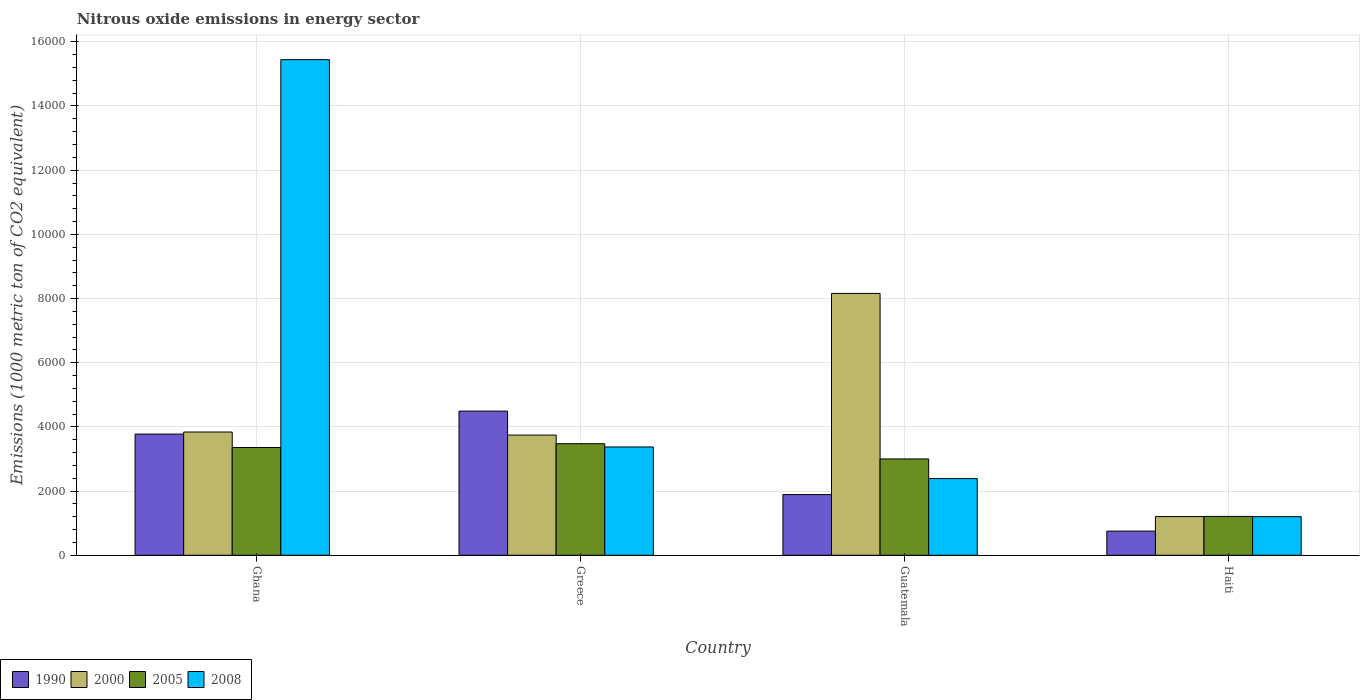What is the label of the 1st group of bars from the left?
Provide a short and direct response. Ghana. In how many cases, is the number of bars for a given country not equal to the number of legend labels?
Ensure brevity in your answer.  0. What is the amount of nitrous oxide emitted in 2008 in Guatemala?
Provide a succinct answer. 2390. Across all countries, what is the maximum amount of nitrous oxide emitted in 1990?
Ensure brevity in your answer.  4492.8. Across all countries, what is the minimum amount of nitrous oxide emitted in 2000?
Provide a short and direct response. 1206.3. In which country was the amount of nitrous oxide emitted in 2008 minimum?
Offer a very short reply. Haiti. What is the total amount of nitrous oxide emitted in 2008 in the graph?
Provide a short and direct response. 2.24e+04. What is the difference between the amount of nitrous oxide emitted in 2005 in Guatemala and that in Haiti?
Offer a very short reply. 1791.3. What is the difference between the amount of nitrous oxide emitted in 2005 in Guatemala and the amount of nitrous oxide emitted in 2000 in Haiti?
Ensure brevity in your answer.  1796.1. What is the average amount of nitrous oxide emitted in 1990 per country?
Keep it short and to the point. 2728.48. What is the difference between the amount of nitrous oxide emitted of/in 2005 and amount of nitrous oxide emitted of/in 1990 in Greece?
Provide a succinct answer. -1015.8. What is the ratio of the amount of nitrous oxide emitted in 1990 in Guatemala to that in Haiti?
Your response must be concise. 2.51. Is the amount of nitrous oxide emitted in 2000 in Guatemala less than that in Haiti?
Ensure brevity in your answer.  No. Is the difference between the amount of nitrous oxide emitted in 2005 in Ghana and Guatemala greater than the difference between the amount of nitrous oxide emitted in 1990 in Ghana and Guatemala?
Give a very brief answer. No. What is the difference between the highest and the second highest amount of nitrous oxide emitted in 2000?
Ensure brevity in your answer.  95.3. What is the difference between the highest and the lowest amount of nitrous oxide emitted in 2008?
Give a very brief answer. 1.42e+04. In how many countries, is the amount of nitrous oxide emitted in 2008 greater than the average amount of nitrous oxide emitted in 2008 taken over all countries?
Provide a short and direct response. 1. Is it the case that in every country, the sum of the amount of nitrous oxide emitted in 2005 and amount of nitrous oxide emitted in 1990 is greater than the sum of amount of nitrous oxide emitted in 2008 and amount of nitrous oxide emitted in 2000?
Offer a terse response. No. What does the 1st bar from the left in Greece represents?
Keep it short and to the point. 1990. Is it the case that in every country, the sum of the amount of nitrous oxide emitted in 2000 and amount of nitrous oxide emitted in 1990 is greater than the amount of nitrous oxide emitted in 2005?
Provide a succinct answer. Yes. Are all the bars in the graph horizontal?
Ensure brevity in your answer.  No. Are the values on the major ticks of Y-axis written in scientific E-notation?
Your answer should be compact. No. Does the graph contain grids?
Your answer should be compact. Yes. How are the legend labels stacked?
Provide a succinct answer. Horizontal. What is the title of the graph?
Keep it short and to the point. Nitrous oxide emissions in energy sector. What is the label or title of the Y-axis?
Provide a short and direct response. Emissions (1000 metric ton of CO2 equivalent). What is the Emissions (1000 metric ton of CO2 equivalent) in 1990 in Ghana?
Ensure brevity in your answer.  3776.4. What is the Emissions (1000 metric ton of CO2 equivalent) in 2000 in Ghana?
Your response must be concise. 3840.8. What is the Emissions (1000 metric ton of CO2 equivalent) of 2005 in Ghana?
Offer a terse response. 3358.7. What is the Emissions (1000 metric ton of CO2 equivalent) in 2008 in Ghana?
Offer a very short reply. 1.54e+04. What is the Emissions (1000 metric ton of CO2 equivalent) of 1990 in Greece?
Provide a succinct answer. 4492.8. What is the Emissions (1000 metric ton of CO2 equivalent) in 2000 in Greece?
Give a very brief answer. 3745.5. What is the Emissions (1000 metric ton of CO2 equivalent) of 2005 in Greece?
Ensure brevity in your answer.  3477. What is the Emissions (1000 metric ton of CO2 equivalent) in 2008 in Greece?
Your answer should be compact. 3375. What is the Emissions (1000 metric ton of CO2 equivalent) in 1990 in Guatemala?
Provide a succinct answer. 1891.2. What is the Emissions (1000 metric ton of CO2 equivalent) in 2000 in Guatemala?
Offer a very short reply. 8159.4. What is the Emissions (1000 metric ton of CO2 equivalent) of 2005 in Guatemala?
Keep it short and to the point. 3002.4. What is the Emissions (1000 metric ton of CO2 equivalent) in 2008 in Guatemala?
Your answer should be very brief. 2390. What is the Emissions (1000 metric ton of CO2 equivalent) of 1990 in Haiti?
Give a very brief answer. 753.5. What is the Emissions (1000 metric ton of CO2 equivalent) in 2000 in Haiti?
Keep it short and to the point. 1206.3. What is the Emissions (1000 metric ton of CO2 equivalent) of 2005 in Haiti?
Make the answer very short. 1211.1. What is the Emissions (1000 metric ton of CO2 equivalent) of 2008 in Haiti?
Give a very brief answer. 1203.2. Across all countries, what is the maximum Emissions (1000 metric ton of CO2 equivalent) of 1990?
Your answer should be very brief. 4492.8. Across all countries, what is the maximum Emissions (1000 metric ton of CO2 equivalent) in 2000?
Keep it short and to the point. 8159.4. Across all countries, what is the maximum Emissions (1000 metric ton of CO2 equivalent) in 2005?
Ensure brevity in your answer.  3477. Across all countries, what is the maximum Emissions (1000 metric ton of CO2 equivalent) of 2008?
Make the answer very short. 1.54e+04. Across all countries, what is the minimum Emissions (1000 metric ton of CO2 equivalent) in 1990?
Your answer should be very brief. 753.5. Across all countries, what is the minimum Emissions (1000 metric ton of CO2 equivalent) in 2000?
Provide a succinct answer. 1206.3. Across all countries, what is the minimum Emissions (1000 metric ton of CO2 equivalent) in 2005?
Your response must be concise. 1211.1. Across all countries, what is the minimum Emissions (1000 metric ton of CO2 equivalent) of 2008?
Offer a very short reply. 1203.2. What is the total Emissions (1000 metric ton of CO2 equivalent) in 1990 in the graph?
Your answer should be very brief. 1.09e+04. What is the total Emissions (1000 metric ton of CO2 equivalent) in 2000 in the graph?
Offer a very short reply. 1.70e+04. What is the total Emissions (1000 metric ton of CO2 equivalent) of 2005 in the graph?
Keep it short and to the point. 1.10e+04. What is the total Emissions (1000 metric ton of CO2 equivalent) of 2008 in the graph?
Provide a succinct answer. 2.24e+04. What is the difference between the Emissions (1000 metric ton of CO2 equivalent) in 1990 in Ghana and that in Greece?
Provide a succinct answer. -716.4. What is the difference between the Emissions (1000 metric ton of CO2 equivalent) of 2000 in Ghana and that in Greece?
Your answer should be compact. 95.3. What is the difference between the Emissions (1000 metric ton of CO2 equivalent) of 2005 in Ghana and that in Greece?
Give a very brief answer. -118.3. What is the difference between the Emissions (1000 metric ton of CO2 equivalent) of 2008 in Ghana and that in Greece?
Offer a terse response. 1.21e+04. What is the difference between the Emissions (1000 metric ton of CO2 equivalent) of 1990 in Ghana and that in Guatemala?
Your answer should be compact. 1885.2. What is the difference between the Emissions (1000 metric ton of CO2 equivalent) of 2000 in Ghana and that in Guatemala?
Your answer should be compact. -4318.6. What is the difference between the Emissions (1000 metric ton of CO2 equivalent) in 2005 in Ghana and that in Guatemala?
Make the answer very short. 356.3. What is the difference between the Emissions (1000 metric ton of CO2 equivalent) of 2008 in Ghana and that in Guatemala?
Offer a terse response. 1.31e+04. What is the difference between the Emissions (1000 metric ton of CO2 equivalent) in 1990 in Ghana and that in Haiti?
Your response must be concise. 3022.9. What is the difference between the Emissions (1000 metric ton of CO2 equivalent) in 2000 in Ghana and that in Haiti?
Offer a very short reply. 2634.5. What is the difference between the Emissions (1000 metric ton of CO2 equivalent) of 2005 in Ghana and that in Haiti?
Ensure brevity in your answer.  2147.6. What is the difference between the Emissions (1000 metric ton of CO2 equivalent) in 2008 in Ghana and that in Haiti?
Keep it short and to the point. 1.42e+04. What is the difference between the Emissions (1000 metric ton of CO2 equivalent) in 1990 in Greece and that in Guatemala?
Offer a terse response. 2601.6. What is the difference between the Emissions (1000 metric ton of CO2 equivalent) of 2000 in Greece and that in Guatemala?
Provide a short and direct response. -4413.9. What is the difference between the Emissions (1000 metric ton of CO2 equivalent) in 2005 in Greece and that in Guatemala?
Keep it short and to the point. 474.6. What is the difference between the Emissions (1000 metric ton of CO2 equivalent) in 2008 in Greece and that in Guatemala?
Your answer should be very brief. 985. What is the difference between the Emissions (1000 metric ton of CO2 equivalent) in 1990 in Greece and that in Haiti?
Offer a terse response. 3739.3. What is the difference between the Emissions (1000 metric ton of CO2 equivalent) in 2000 in Greece and that in Haiti?
Provide a short and direct response. 2539.2. What is the difference between the Emissions (1000 metric ton of CO2 equivalent) of 2005 in Greece and that in Haiti?
Offer a very short reply. 2265.9. What is the difference between the Emissions (1000 metric ton of CO2 equivalent) in 2008 in Greece and that in Haiti?
Your response must be concise. 2171.8. What is the difference between the Emissions (1000 metric ton of CO2 equivalent) of 1990 in Guatemala and that in Haiti?
Your answer should be very brief. 1137.7. What is the difference between the Emissions (1000 metric ton of CO2 equivalent) of 2000 in Guatemala and that in Haiti?
Provide a succinct answer. 6953.1. What is the difference between the Emissions (1000 metric ton of CO2 equivalent) of 2005 in Guatemala and that in Haiti?
Your response must be concise. 1791.3. What is the difference between the Emissions (1000 metric ton of CO2 equivalent) in 2008 in Guatemala and that in Haiti?
Provide a short and direct response. 1186.8. What is the difference between the Emissions (1000 metric ton of CO2 equivalent) of 1990 in Ghana and the Emissions (1000 metric ton of CO2 equivalent) of 2000 in Greece?
Your answer should be very brief. 30.9. What is the difference between the Emissions (1000 metric ton of CO2 equivalent) in 1990 in Ghana and the Emissions (1000 metric ton of CO2 equivalent) in 2005 in Greece?
Give a very brief answer. 299.4. What is the difference between the Emissions (1000 metric ton of CO2 equivalent) of 1990 in Ghana and the Emissions (1000 metric ton of CO2 equivalent) of 2008 in Greece?
Provide a short and direct response. 401.4. What is the difference between the Emissions (1000 metric ton of CO2 equivalent) in 2000 in Ghana and the Emissions (1000 metric ton of CO2 equivalent) in 2005 in Greece?
Your response must be concise. 363.8. What is the difference between the Emissions (1000 metric ton of CO2 equivalent) in 2000 in Ghana and the Emissions (1000 metric ton of CO2 equivalent) in 2008 in Greece?
Ensure brevity in your answer.  465.8. What is the difference between the Emissions (1000 metric ton of CO2 equivalent) in 2005 in Ghana and the Emissions (1000 metric ton of CO2 equivalent) in 2008 in Greece?
Offer a very short reply. -16.3. What is the difference between the Emissions (1000 metric ton of CO2 equivalent) in 1990 in Ghana and the Emissions (1000 metric ton of CO2 equivalent) in 2000 in Guatemala?
Ensure brevity in your answer.  -4383. What is the difference between the Emissions (1000 metric ton of CO2 equivalent) of 1990 in Ghana and the Emissions (1000 metric ton of CO2 equivalent) of 2005 in Guatemala?
Ensure brevity in your answer.  774. What is the difference between the Emissions (1000 metric ton of CO2 equivalent) of 1990 in Ghana and the Emissions (1000 metric ton of CO2 equivalent) of 2008 in Guatemala?
Your response must be concise. 1386.4. What is the difference between the Emissions (1000 metric ton of CO2 equivalent) in 2000 in Ghana and the Emissions (1000 metric ton of CO2 equivalent) in 2005 in Guatemala?
Offer a very short reply. 838.4. What is the difference between the Emissions (1000 metric ton of CO2 equivalent) of 2000 in Ghana and the Emissions (1000 metric ton of CO2 equivalent) of 2008 in Guatemala?
Your response must be concise. 1450.8. What is the difference between the Emissions (1000 metric ton of CO2 equivalent) in 2005 in Ghana and the Emissions (1000 metric ton of CO2 equivalent) in 2008 in Guatemala?
Your answer should be very brief. 968.7. What is the difference between the Emissions (1000 metric ton of CO2 equivalent) in 1990 in Ghana and the Emissions (1000 metric ton of CO2 equivalent) in 2000 in Haiti?
Provide a short and direct response. 2570.1. What is the difference between the Emissions (1000 metric ton of CO2 equivalent) in 1990 in Ghana and the Emissions (1000 metric ton of CO2 equivalent) in 2005 in Haiti?
Give a very brief answer. 2565.3. What is the difference between the Emissions (1000 metric ton of CO2 equivalent) in 1990 in Ghana and the Emissions (1000 metric ton of CO2 equivalent) in 2008 in Haiti?
Offer a terse response. 2573.2. What is the difference between the Emissions (1000 metric ton of CO2 equivalent) of 2000 in Ghana and the Emissions (1000 metric ton of CO2 equivalent) of 2005 in Haiti?
Your response must be concise. 2629.7. What is the difference between the Emissions (1000 metric ton of CO2 equivalent) in 2000 in Ghana and the Emissions (1000 metric ton of CO2 equivalent) in 2008 in Haiti?
Keep it short and to the point. 2637.6. What is the difference between the Emissions (1000 metric ton of CO2 equivalent) in 2005 in Ghana and the Emissions (1000 metric ton of CO2 equivalent) in 2008 in Haiti?
Your answer should be very brief. 2155.5. What is the difference between the Emissions (1000 metric ton of CO2 equivalent) in 1990 in Greece and the Emissions (1000 metric ton of CO2 equivalent) in 2000 in Guatemala?
Offer a very short reply. -3666.6. What is the difference between the Emissions (1000 metric ton of CO2 equivalent) of 1990 in Greece and the Emissions (1000 metric ton of CO2 equivalent) of 2005 in Guatemala?
Provide a short and direct response. 1490.4. What is the difference between the Emissions (1000 metric ton of CO2 equivalent) in 1990 in Greece and the Emissions (1000 metric ton of CO2 equivalent) in 2008 in Guatemala?
Your answer should be very brief. 2102.8. What is the difference between the Emissions (1000 metric ton of CO2 equivalent) of 2000 in Greece and the Emissions (1000 metric ton of CO2 equivalent) of 2005 in Guatemala?
Offer a very short reply. 743.1. What is the difference between the Emissions (1000 metric ton of CO2 equivalent) in 2000 in Greece and the Emissions (1000 metric ton of CO2 equivalent) in 2008 in Guatemala?
Your answer should be very brief. 1355.5. What is the difference between the Emissions (1000 metric ton of CO2 equivalent) in 2005 in Greece and the Emissions (1000 metric ton of CO2 equivalent) in 2008 in Guatemala?
Your answer should be compact. 1087. What is the difference between the Emissions (1000 metric ton of CO2 equivalent) of 1990 in Greece and the Emissions (1000 metric ton of CO2 equivalent) of 2000 in Haiti?
Offer a terse response. 3286.5. What is the difference between the Emissions (1000 metric ton of CO2 equivalent) in 1990 in Greece and the Emissions (1000 metric ton of CO2 equivalent) in 2005 in Haiti?
Your answer should be compact. 3281.7. What is the difference between the Emissions (1000 metric ton of CO2 equivalent) of 1990 in Greece and the Emissions (1000 metric ton of CO2 equivalent) of 2008 in Haiti?
Keep it short and to the point. 3289.6. What is the difference between the Emissions (1000 metric ton of CO2 equivalent) in 2000 in Greece and the Emissions (1000 metric ton of CO2 equivalent) in 2005 in Haiti?
Keep it short and to the point. 2534.4. What is the difference between the Emissions (1000 metric ton of CO2 equivalent) in 2000 in Greece and the Emissions (1000 metric ton of CO2 equivalent) in 2008 in Haiti?
Offer a terse response. 2542.3. What is the difference between the Emissions (1000 metric ton of CO2 equivalent) of 2005 in Greece and the Emissions (1000 metric ton of CO2 equivalent) of 2008 in Haiti?
Your answer should be very brief. 2273.8. What is the difference between the Emissions (1000 metric ton of CO2 equivalent) in 1990 in Guatemala and the Emissions (1000 metric ton of CO2 equivalent) in 2000 in Haiti?
Provide a short and direct response. 684.9. What is the difference between the Emissions (1000 metric ton of CO2 equivalent) of 1990 in Guatemala and the Emissions (1000 metric ton of CO2 equivalent) of 2005 in Haiti?
Make the answer very short. 680.1. What is the difference between the Emissions (1000 metric ton of CO2 equivalent) of 1990 in Guatemala and the Emissions (1000 metric ton of CO2 equivalent) of 2008 in Haiti?
Your answer should be compact. 688. What is the difference between the Emissions (1000 metric ton of CO2 equivalent) in 2000 in Guatemala and the Emissions (1000 metric ton of CO2 equivalent) in 2005 in Haiti?
Ensure brevity in your answer.  6948.3. What is the difference between the Emissions (1000 metric ton of CO2 equivalent) of 2000 in Guatemala and the Emissions (1000 metric ton of CO2 equivalent) of 2008 in Haiti?
Your answer should be compact. 6956.2. What is the difference between the Emissions (1000 metric ton of CO2 equivalent) in 2005 in Guatemala and the Emissions (1000 metric ton of CO2 equivalent) in 2008 in Haiti?
Your answer should be very brief. 1799.2. What is the average Emissions (1000 metric ton of CO2 equivalent) in 1990 per country?
Offer a very short reply. 2728.47. What is the average Emissions (1000 metric ton of CO2 equivalent) of 2000 per country?
Give a very brief answer. 4238. What is the average Emissions (1000 metric ton of CO2 equivalent) of 2005 per country?
Make the answer very short. 2762.3. What is the average Emissions (1000 metric ton of CO2 equivalent) in 2008 per country?
Keep it short and to the point. 5603.07. What is the difference between the Emissions (1000 metric ton of CO2 equivalent) of 1990 and Emissions (1000 metric ton of CO2 equivalent) of 2000 in Ghana?
Your answer should be compact. -64.4. What is the difference between the Emissions (1000 metric ton of CO2 equivalent) in 1990 and Emissions (1000 metric ton of CO2 equivalent) in 2005 in Ghana?
Your answer should be compact. 417.7. What is the difference between the Emissions (1000 metric ton of CO2 equivalent) of 1990 and Emissions (1000 metric ton of CO2 equivalent) of 2008 in Ghana?
Make the answer very short. -1.17e+04. What is the difference between the Emissions (1000 metric ton of CO2 equivalent) in 2000 and Emissions (1000 metric ton of CO2 equivalent) in 2005 in Ghana?
Your response must be concise. 482.1. What is the difference between the Emissions (1000 metric ton of CO2 equivalent) of 2000 and Emissions (1000 metric ton of CO2 equivalent) of 2008 in Ghana?
Offer a very short reply. -1.16e+04. What is the difference between the Emissions (1000 metric ton of CO2 equivalent) in 2005 and Emissions (1000 metric ton of CO2 equivalent) in 2008 in Ghana?
Keep it short and to the point. -1.21e+04. What is the difference between the Emissions (1000 metric ton of CO2 equivalent) of 1990 and Emissions (1000 metric ton of CO2 equivalent) of 2000 in Greece?
Make the answer very short. 747.3. What is the difference between the Emissions (1000 metric ton of CO2 equivalent) in 1990 and Emissions (1000 metric ton of CO2 equivalent) in 2005 in Greece?
Your answer should be very brief. 1015.8. What is the difference between the Emissions (1000 metric ton of CO2 equivalent) in 1990 and Emissions (1000 metric ton of CO2 equivalent) in 2008 in Greece?
Give a very brief answer. 1117.8. What is the difference between the Emissions (1000 metric ton of CO2 equivalent) of 2000 and Emissions (1000 metric ton of CO2 equivalent) of 2005 in Greece?
Provide a succinct answer. 268.5. What is the difference between the Emissions (1000 metric ton of CO2 equivalent) of 2000 and Emissions (1000 metric ton of CO2 equivalent) of 2008 in Greece?
Your response must be concise. 370.5. What is the difference between the Emissions (1000 metric ton of CO2 equivalent) of 2005 and Emissions (1000 metric ton of CO2 equivalent) of 2008 in Greece?
Provide a succinct answer. 102. What is the difference between the Emissions (1000 metric ton of CO2 equivalent) of 1990 and Emissions (1000 metric ton of CO2 equivalent) of 2000 in Guatemala?
Ensure brevity in your answer.  -6268.2. What is the difference between the Emissions (1000 metric ton of CO2 equivalent) in 1990 and Emissions (1000 metric ton of CO2 equivalent) in 2005 in Guatemala?
Provide a succinct answer. -1111.2. What is the difference between the Emissions (1000 metric ton of CO2 equivalent) in 1990 and Emissions (1000 metric ton of CO2 equivalent) in 2008 in Guatemala?
Make the answer very short. -498.8. What is the difference between the Emissions (1000 metric ton of CO2 equivalent) in 2000 and Emissions (1000 metric ton of CO2 equivalent) in 2005 in Guatemala?
Offer a very short reply. 5157. What is the difference between the Emissions (1000 metric ton of CO2 equivalent) in 2000 and Emissions (1000 metric ton of CO2 equivalent) in 2008 in Guatemala?
Make the answer very short. 5769.4. What is the difference between the Emissions (1000 metric ton of CO2 equivalent) of 2005 and Emissions (1000 metric ton of CO2 equivalent) of 2008 in Guatemala?
Make the answer very short. 612.4. What is the difference between the Emissions (1000 metric ton of CO2 equivalent) in 1990 and Emissions (1000 metric ton of CO2 equivalent) in 2000 in Haiti?
Your answer should be compact. -452.8. What is the difference between the Emissions (1000 metric ton of CO2 equivalent) of 1990 and Emissions (1000 metric ton of CO2 equivalent) of 2005 in Haiti?
Give a very brief answer. -457.6. What is the difference between the Emissions (1000 metric ton of CO2 equivalent) of 1990 and Emissions (1000 metric ton of CO2 equivalent) of 2008 in Haiti?
Ensure brevity in your answer.  -449.7. What is the difference between the Emissions (1000 metric ton of CO2 equivalent) in 2000 and Emissions (1000 metric ton of CO2 equivalent) in 2005 in Haiti?
Offer a terse response. -4.8. What is the difference between the Emissions (1000 metric ton of CO2 equivalent) of 2000 and Emissions (1000 metric ton of CO2 equivalent) of 2008 in Haiti?
Make the answer very short. 3.1. What is the ratio of the Emissions (1000 metric ton of CO2 equivalent) of 1990 in Ghana to that in Greece?
Provide a succinct answer. 0.84. What is the ratio of the Emissions (1000 metric ton of CO2 equivalent) of 2000 in Ghana to that in Greece?
Offer a very short reply. 1.03. What is the ratio of the Emissions (1000 metric ton of CO2 equivalent) in 2008 in Ghana to that in Greece?
Keep it short and to the point. 4.58. What is the ratio of the Emissions (1000 metric ton of CO2 equivalent) of 1990 in Ghana to that in Guatemala?
Your answer should be very brief. 2. What is the ratio of the Emissions (1000 metric ton of CO2 equivalent) in 2000 in Ghana to that in Guatemala?
Your answer should be compact. 0.47. What is the ratio of the Emissions (1000 metric ton of CO2 equivalent) in 2005 in Ghana to that in Guatemala?
Your answer should be compact. 1.12. What is the ratio of the Emissions (1000 metric ton of CO2 equivalent) in 2008 in Ghana to that in Guatemala?
Offer a very short reply. 6.46. What is the ratio of the Emissions (1000 metric ton of CO2 equivalent) in 1990 in Ghana to that in Haiti?
Your answer should be very brief. 5.01. What is the ratio of the Emissions (1000 metric ton of CO2 equivalent) in 2000 in Ghana to that in Haiti?
Provide a short and direct response. 3.18. What is the ratio of the Emissions (1000 metric ton of CO2 equivalent) in 2005 in Ghana to that in Haiti?
Give a very brief answer. 2.77. What is the ratio of the Emissions (1000 metric ton of CO2 equivalent) in 2008 in Ghana to that in Haiti?
Offer a terse response. 12.84. What is the ratio of the Emissions (1000 metric ton of CO2 equivalent) of 1990 in Greece to that in Guatemala?
Your response must be concise. 2.38. What is the ratio of the Emissions (1000 metric ton of CO2 equivalent) of 2000 in Greece to that in Guatemala?
Your answer should be very brief. 0.46. What is the ratio of the Emissions (1000 metric ton of CO2 equivalent) in 2005 in Greece to that in Guatemala?
Ensure brevity in your answer.  1.16. What is the ratio of the Emissions (1000 metric ton of CO2 equivalent) of 2008 in Greece to that in Guatemala?
Keep it short and to the point. 1.41. What is the ratio of the Emissions (1000 metric ton of CO2 equivalent) of 1990 in Greece to that in Haiti?
Make the answer very short. 5.96. What is the ratio of the Emissions (1000 metric ton of CO2 equivalent) of 2000 in Greece to that in Haiti?
Offer a very short reply. 3.1. What is the ratio of the Emissions (1000 metric ton of CO2 equivalent) in 2005 in Greece to that in Haiti?
Provide a succinct answer. 2.87. What is the ratio of the Emissions (1000 metric ton of CO2 equivalent) in 2008 in Greece to that in Haiti?
Give a very brief answer. 2.81. What is the ratio of the Emissions (1000 metric ton of CO2 equivalent) of 1990 in Guatemala to that in Haiti?
Give a very brief answer. 2.51. What is the ratio of the Emissions (1000 metric ton of CO2 equivalent) in 2000 in Guatemala to that in Haiti?
Offer a very short reply. 6.76. What is the ratio of the Emissions (1000 metric ton of CO2 equivalent) of 2005 in Guatemala to that in Haiti?
Your answer should be compact. 2.48. What is the ratio of the Emissions (1000 metric ton of CO2 equivalent) of 2008 in Guatemala to that in Haiti?
Provide a succinct answer. 1.99. What is the difference between the highest and the second highest Emissions (1000 metric ton of CO2 equivalent) of 1990?
Offer a terse response. 716.4. What is the difference between the highest and the second highest Emissions (1000 metric ton of CO2 equivalent) of 2000?
Make the answer very short. 4318.6. What is the difference between the highest and the second highest Emissions (1000 metric ton of CO2 equivalent) of 2005?
Offer a very short reply. 118.3. What is the difference between the highest and the second highest Emissions (1000 metric ton of CO2 equivalent) of 2008?
Provide a succinct answer. 1.21e+04. What is the difference between the highest and the lowest Emissions (1000 metric ton of CO2 equivalent) of 1990?
Your response must be concise. 3739.3. What is the difference between the highest and the lowest Emissions (1000 metric ton of CO2 equivalent) in 2000?
Keep it short and to the point. 6953.1. What is the difference between the highest and the lowest Emissions (1000 metric ton of CO2 equivalent) in 2005?
Ensure brevity in your answer.  2265.9. What is the difference between the highest and the lowest Emissions (1000 metric ton of CO2 equivalent) in 2008?
Provide a short and direct response. 1.42e+04. 